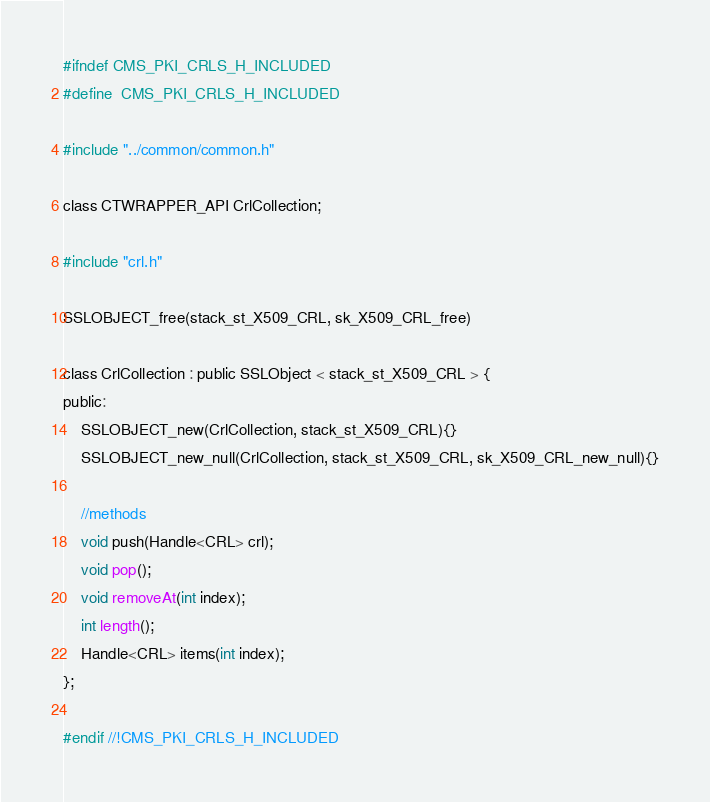<code> <loc_0><loc_0><loc_500><loc_500><_C_>#ifndef CMS_PKI_CRLS_H_INCLUDED
#define  CMS_PKI_CRLS_H_INCLUDED

#include "../common/common.h"

class CTWRAPPER_API CrlCollection;

#include "crl.h"

SSLOBJECT_free(stack_st_X509_CRL, sk_X509_CRL_free)

class CrlCollection : public SSLObject < stack_st_X509_CRL > {
public:
	SSLOBJECT_new(CrlCollection, stack_st_X509_CRL){}
	SSLOBJECT_new_null(CrlCollection, stack_st_X509_CRL, sk_X509_CRL_new_null){}

	//methods
	void push(Handle<CRL> crl);
	void pop();
	void removeAt(int index);
	int length();
	Handle<CRL> items(int index);
};

#endif //!CMS_PKI_CRLS_H_INCLUDED
</code> 